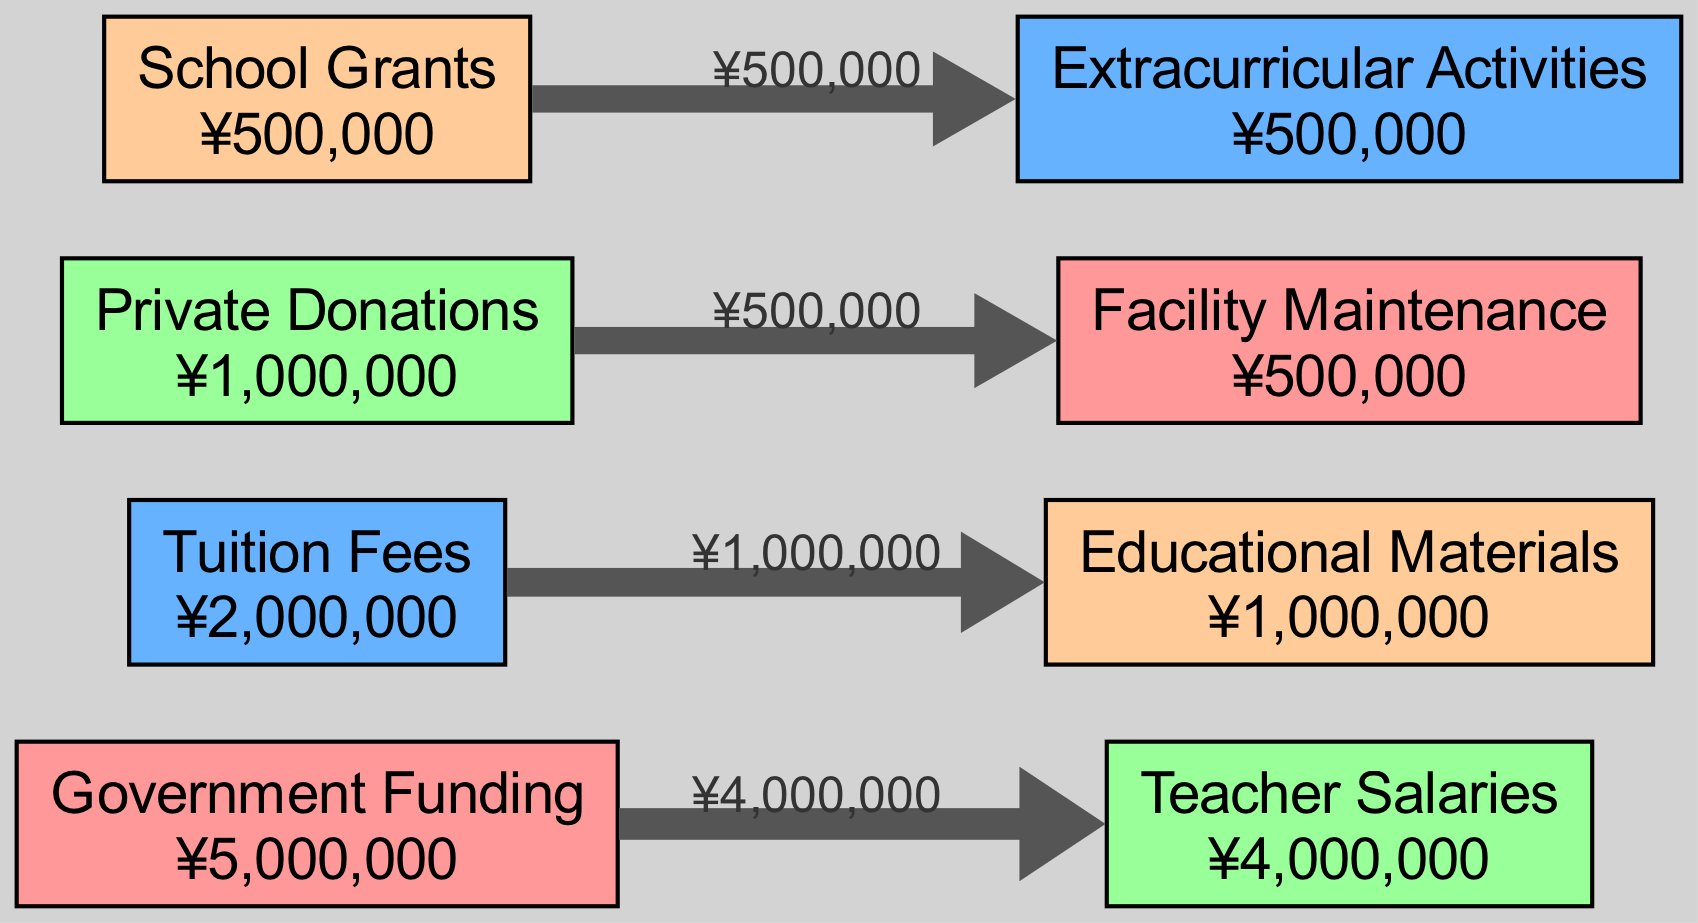What is the total amount of Government Funding? In the diagram, the node labeled "Government Funding" has the amount ¥5,000,000 displayed. This directly answers the question about the total amount for that specific source.
Answer: ¥5,000,000 How much is allocated to Teacher Salaries? The node labeled "Teacher Salaries" shows an amount of ¥4,000,000. Therefore, this is the amount allocated to that category of spending.
Answer: ¥4,000,000 What is the relationship between Tuition Fees and Educational Materials? The diagram shows an edge (or flow) going from "Tuition Fees" to "Educational Materials" with an amount of ¥1,000,000. This direct connection indicates that Tuition Fees directly support Educational Materials by that amount.
Answer: ¥1,000,000 How many categories of spending are represented? The diagram has four distinct category nodes: Teacher Salaries, Educational Materials, Facility Maintenance, and Extracurricular Activities, which indicates that there are four categories.
Answer: 4 Which source contributes to Facility Maintenance? The edge going from "Private Donations" to "Facility Maintenance" clearly indicates that Private Donations are the source that contributes to this category.
Answer: Private Donations How much of the total budget comes from Tuition Fees? To find this, look at the amount displayed for "Tuition Fees," which is ¥2,000,000. This is how much of the total budget is sourced from Tuition Fees.
Answer: ¥2,000,000 What is the total amount for Extracurricular Activities? The node labeled "Extracurricular Activities" indicates an amount of ¥500,000. This is the total designated for this category.
Answer: ¥500,000 Which funding source has the least amount allocated? "School Grants" has an amount of ¥500,000, which is less than the other shown sources (Government Funding, Tuition Fees, and Private Donations), making it the least.
Answer: School Grants Which category receives funds from School Grants? The diagram shows an edge leading from "School Grants" to "Extracurricular Activities," indicating that this is the category receiving funds from that source.
Answer: Extracurricular Activities 